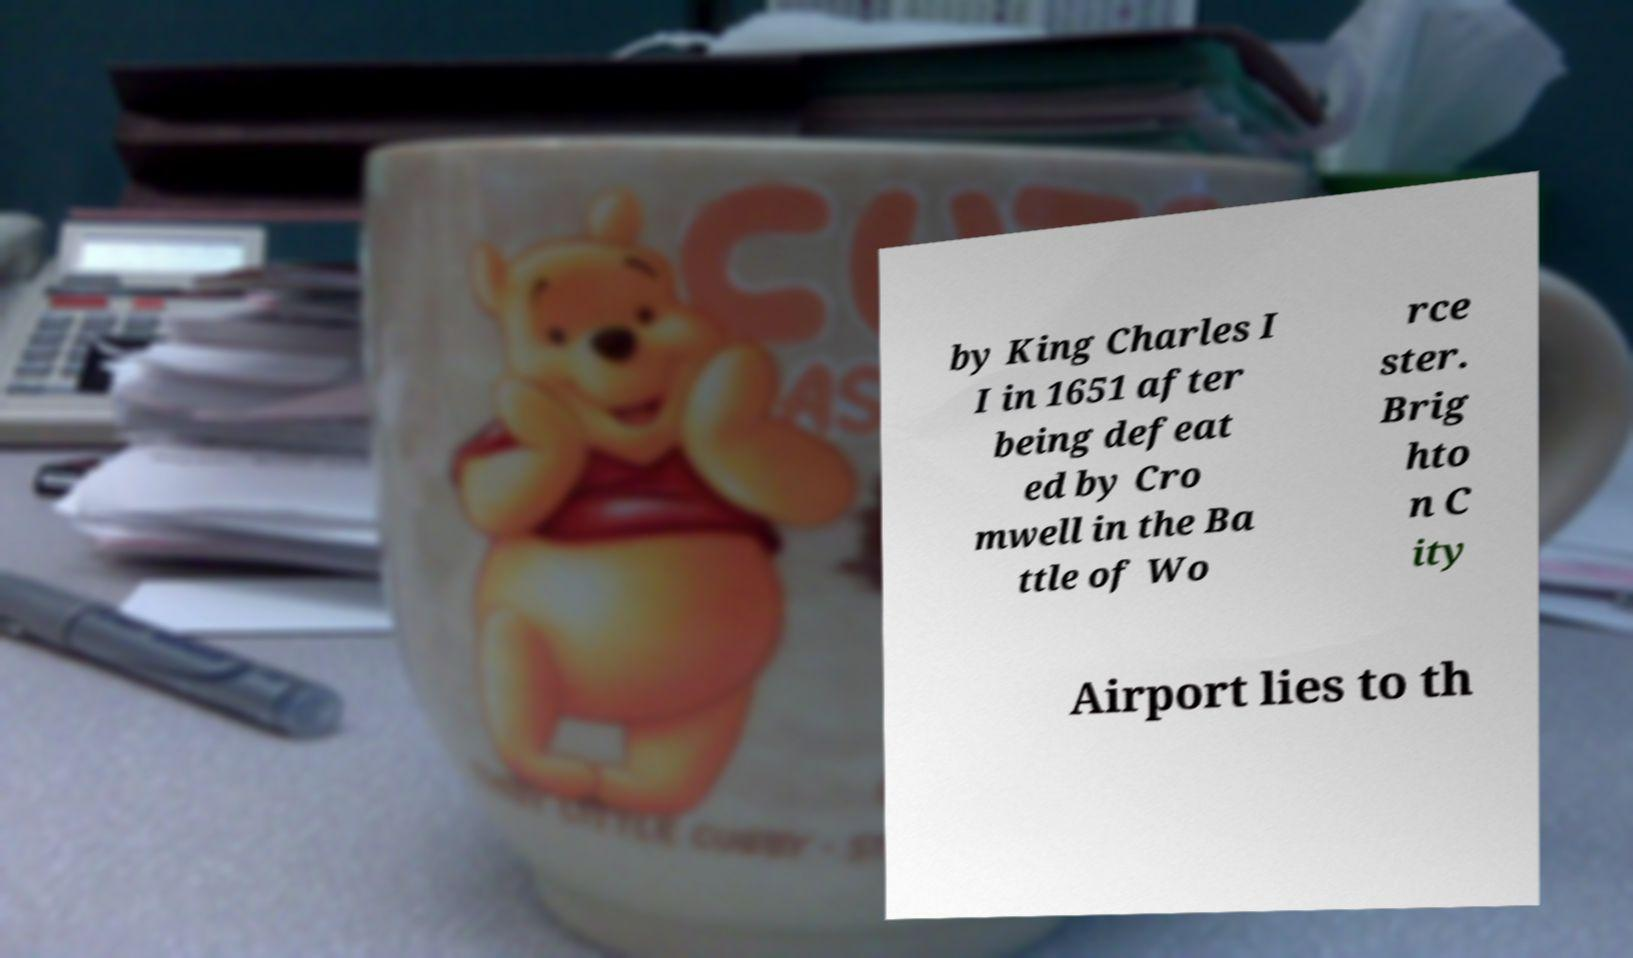Could you assist in decoding the text presented in this image and type it out clearly? by King Charles I I in 1651 after being defeat ed by Cro mwell in the Ba ttle of Wo rce ster. Brig hto n C ity Airport lies to th 